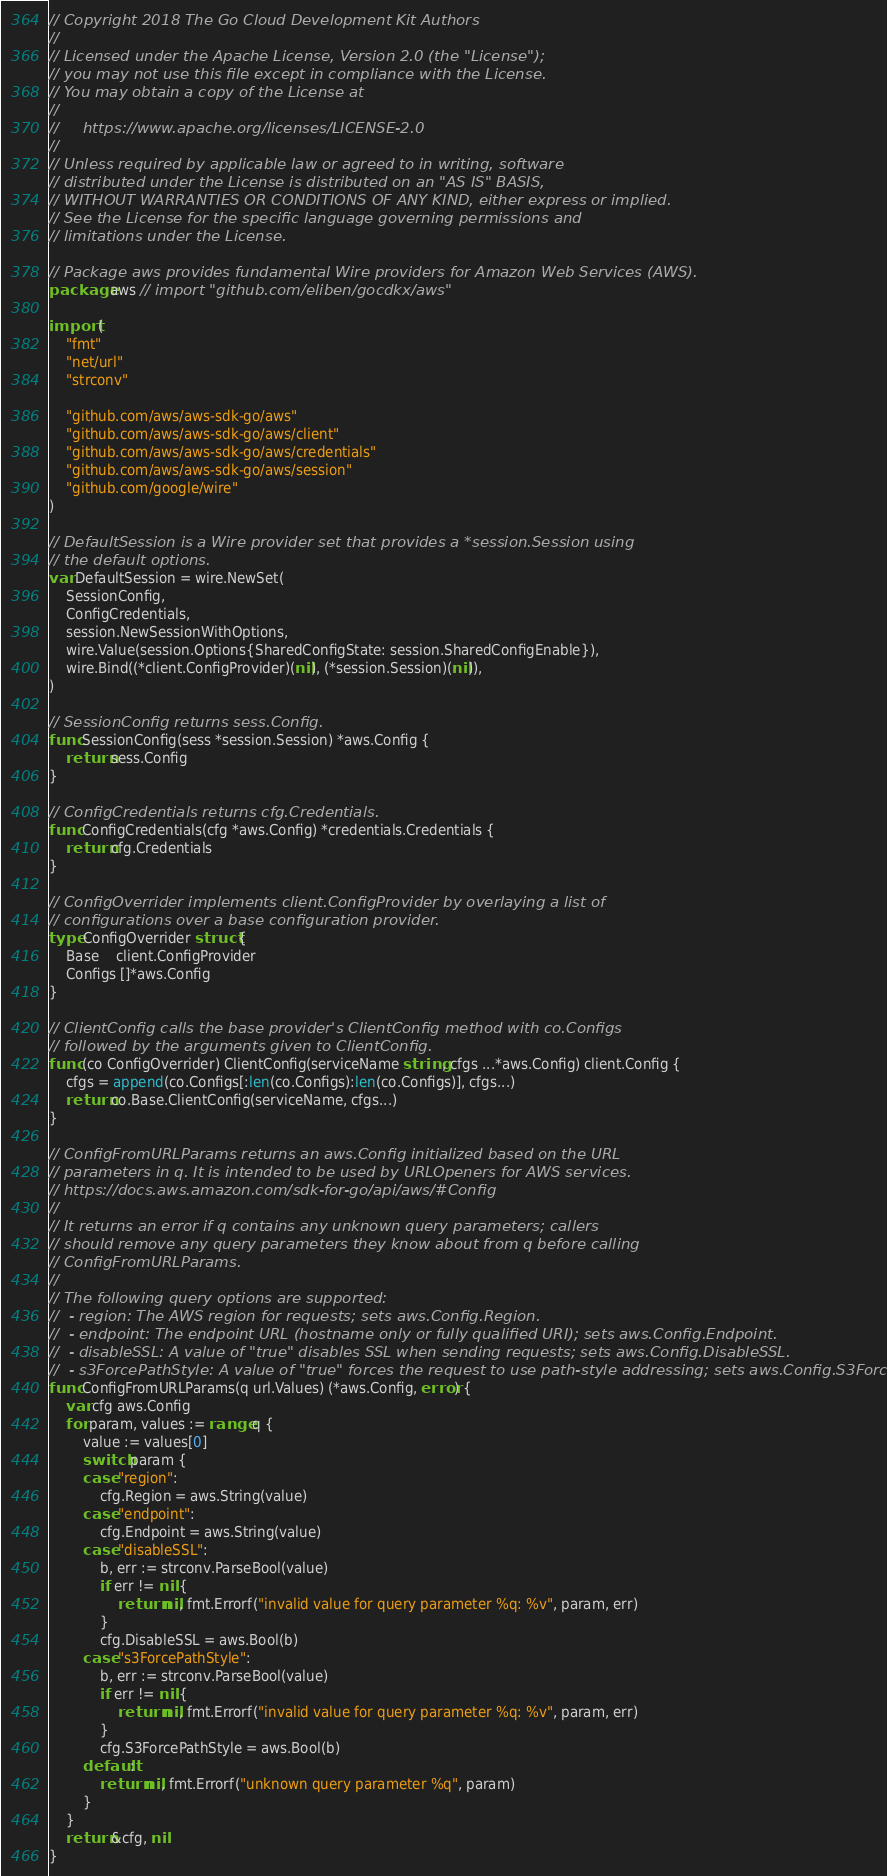<code> <loc_0><loc_0><loc_500><loc_500><_Go_>// Copyright 2018 The Go Cloud Development Kit Authors
//
// Licensed under the Apache License, Version 2.0 (the "License");
// you may not use this file except in compliance with the License.
// You may obtain a copy of the License at
//
//     https://www.apache.org/licenses/LICENSE-2.0
//
// Unless required by applicable law or agreed to in writing, software
// distributed under the License is distributed on an "AS IS" BASIS,
// WITHOUT WARRANTIES OR CONDITIONS OF ANY KIND, either express or implied.
// See the License for the specific language governing permissions and
// limitations under the License.

// Package aws provides fundamental Wire providers for Amazon Web Services (AWS).
package aws // import "github.com/eliben/gocdkx/aws"

import (
	"fmt"
	"net/url"
	"strconv"

	"github.com/aws/aws-sdk-go/aws"
	"github.com/aws/aws-sdk-go/aws/client"
	"github.com/aws/aws-sdk-go/aws/credentials"
	"github.com/aws/aws-sdk-go/aws/session"
	"github.com/google/wire"
)

// DefaultSession is a Wire provider set that provides a *session.Session using
// the default options.
var DefaultSession = wire.NewSet(
	SessionConfig,
	ConfigCredentials,
	session.NewSessionWithOptions,
	wire.Value(session.Options{SharedConfigState: session.SharedConfigEnable}),
	wire.Bind((*client.ConfigProvider)(nil), (*session.Session)(nil)),
)

// SessionConfig returns sess.Config.
func SessionConfig(sess *session.Session) *aws.Config {
	return sess.Config
}

// ConfigCredentials returns cfg.Credentials.
func ConfigCredentials(cfg *aws.Config) *credentials.Credentials {
	return cfg.Credentials
}

// ConfigOverrider implements client.ConfigProvider by overlaying a list of
// configurations over a base configuration provider.
type ConfigOverrider struct {
	Base    client.ConfigProvider
	Configs []*aws.Config
}

// ClientConfig calls the base provider's ClientConfig method with co.Configs
// followed by the arguments given to ClientConfig.
func (co ConfigOverrider) ClientConfig(serviceName string, cfgs ...*aws.Config) client.Config {
	cfgs = append(co.Configs[:len(co.Configs):len(co.Configs)], cfgs...)
	return co.Base.ClientConfig(serviceName, cfgs...)
}

// ConfigFromURLParams returns an aws.Config initialized based on the URL
// parameters in q. It is intended to be used by URLOpeners for AWS services.
// https://docs.aws.amazon.com/sdk-for-go/api/aws/#Config
//
// It returns an error if q contains any unknown query parameters; callers
// should remove any query parameters they know about from q before calling
// ConfigFromURLParams.
//
// The following query options are supported:
//  - region: The AWS region for requests; sets aws.Config.Region.
//  - endpoint: The endpoint URL (hostname only or fully qualified URI); sets aws.Config.Endpoint.
//  - disableSSL: A value of "true" disables SSL when sending requests; sets aws.Config.DisableSSL.
//  - s3ForcePathStyle: A value of "true" forces the request to use path-style addressing; sets aws.Config.S3ForcePathStyle.
func ConfigFromURLParams(q url.Values) (*aws.Config, error) {
	var cfg aws.Config
	for param, values := range q {
		value := values[0]
		switch param {
		case "region":
			cfg.Region = aws.String(value)
		case "endpoint":
			cfg.Endpoint = aws.String(value)
		case "disableSSL":
			b, err := strconv.ParseBool(value)
			if err != nil {
				return nil, fmt.Errorf("invalid value for query parameter %q: %v", param, err)
			}
			cfg.DisableSSL = aws.Bool(b)
		case "s3ForcePathStyle":
			b, err := strconv.ParseBool(value)
			if err != nil {
				return nil, fmt.Errorf("invalid value for query parameter %q: %v", param, err)
			}
			cfg.S3ForcePathStyle = aws.Bool(b)
		default:
			return nil, fmt.Errorf("unknown query parameter %q", param)
		}
	}
	return &cfg, nil
}
</code> 